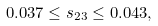<formula> <loc_0><loc_0><loc_500><loc_500>0 . 0 3 7 \leq s _ { 2 3 } \leq 0 . 0 4 3 ,</formula> 